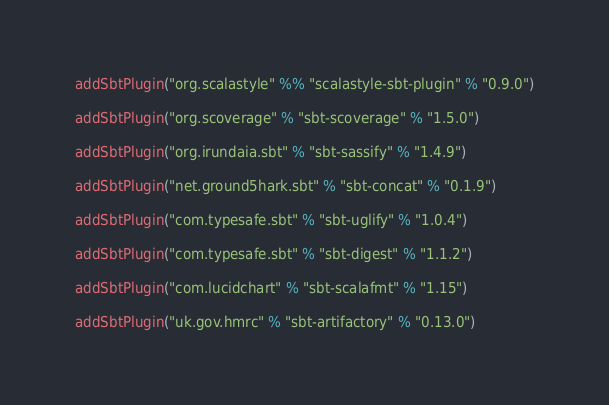<code> <loc_0><loc_0><loc_500><loc_500><_Scala_>
addSbtPlugin("org.scalastyle" %% "scalastyle-sbt-plugin" % "0.9.0")

addSbtPlugin("org.scoverage" % "sbt-scoverage" % "1.5.0")

addSbtPlugin("org.irundaia.sbt" % "sbt-sassify" % "1.4.9")

addSbtPlugin("net.ground5hark.sbt" % "sbt-concat" % "0.1.9")

addSbtPlugin("com.typesafe.sbt" % "sbt-uglify" % "1.0.4")

addSbtPlugin("com.typesafe.sbt" % "sbt-digest" % "1.1.2")

addSbtPlugin("com.lucidchart" % "sbt-scalafmt" % "1.15")

addSbtPlugin("uk.gov.hmrc" % "sbt-artifactory" % "0.13.0")
</code> 